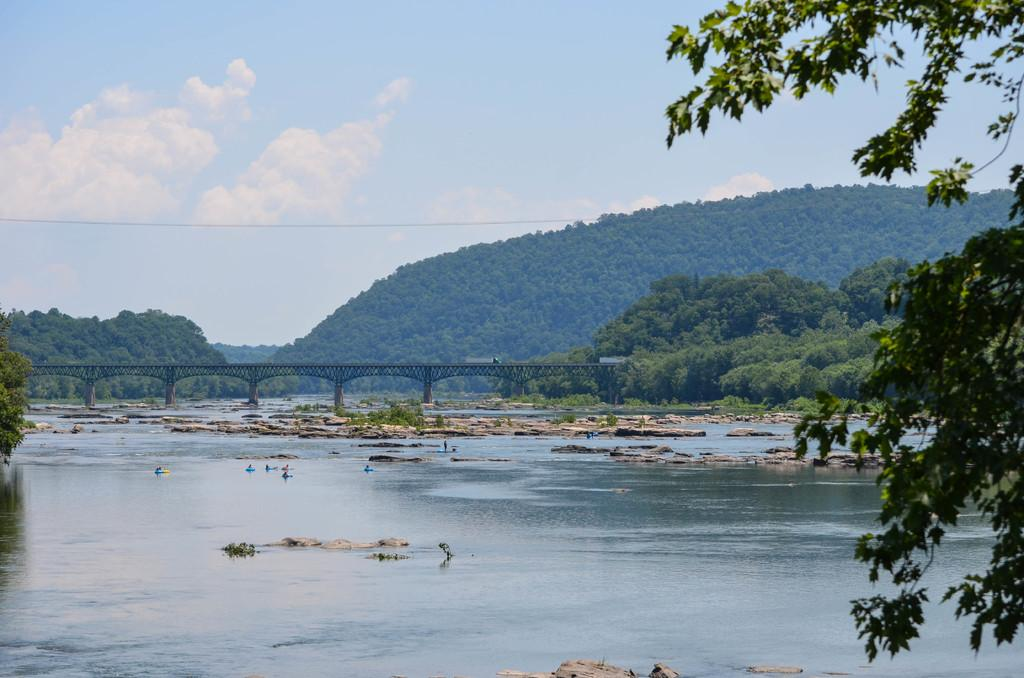What type of natural feature is present in the image? There is a lake in the image. What man-made structure can be seen in the image? There is a bridge in the image. What type of vegetation is present in the image? There are trees in the image. What type of geographical feature is visible in the distance? There is a mountain in the backdrop of the image. What type of music can be heard coming from the lake in the image? There is no music present in the image; it is a visual representation of a lake, bridge, trees, and a mountain. 